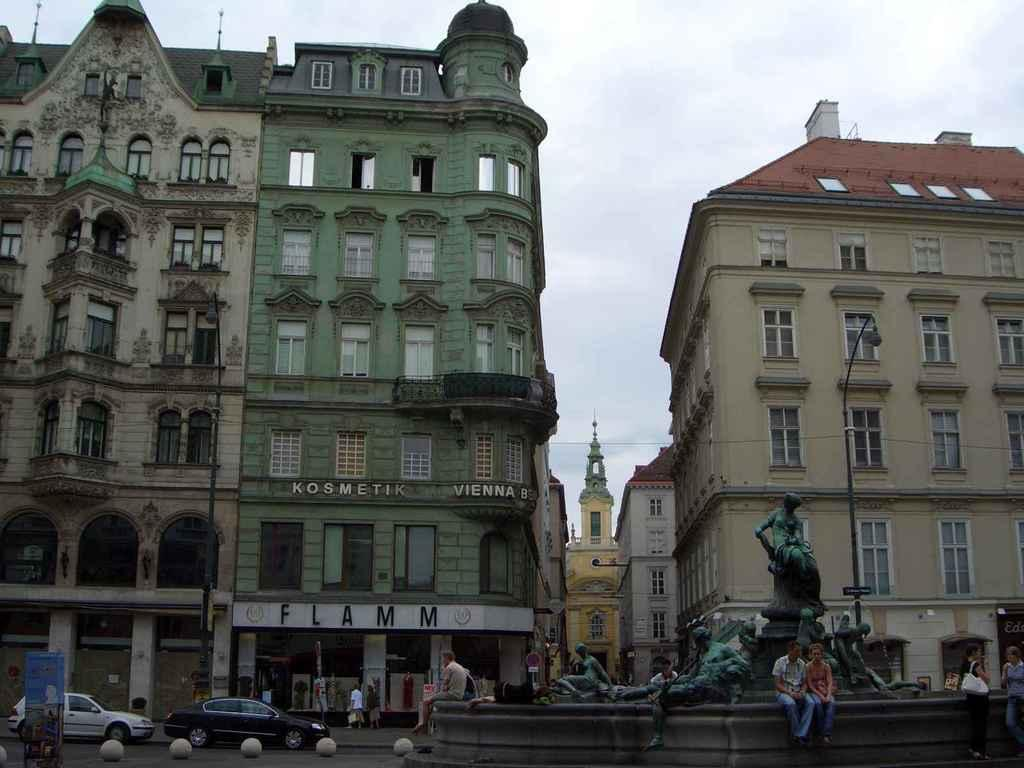<image>
Render a clear and concise summary of the photo. A shop called Flamm sits below a Kosmetik shop 